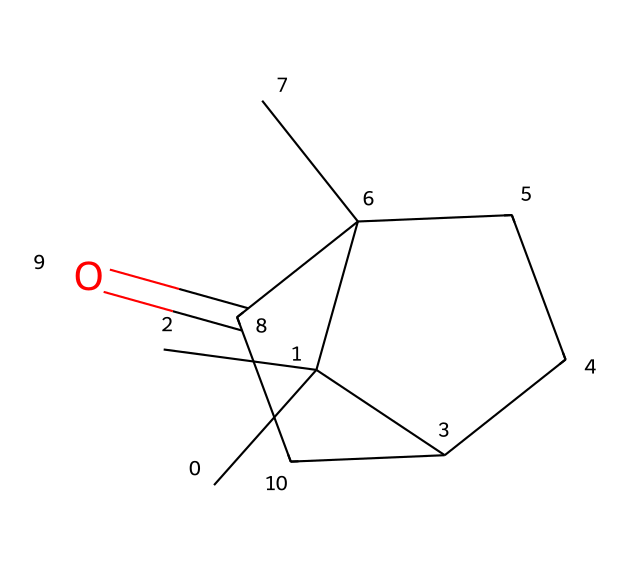How many carbon atoms are present in camphor? By analyzing the SMILES representation, we note each 'C' indicates a carbon atom. Counting all the 'C's in the structure shows there are ten carbon atoms in total.
Answer: ten What type of functional group is present in camphor? The structure contains a carbonyl group, indicated by the 'C(=O)' portion, which is characteristic of ketones. Therefore, the functional group in this compound is a ketone.
Answer: ketone How many rings are present in the structure of camphor? The structure of camphor presents two interconnected rings, as indicated by the cycloalkane format seen in the SMILES. Each cycloalkane contributes to the ring structure.
Answer: two What is the degree of saturation of camphor? The formula for calculating the degree of saturation (DBE) is the number of rings plus the number of double bonds. Camphor has two rings and one carbonyl; thus, the degree of saturation is two.
Answer: two What is the molecular formula of camphor? By analyzing the counts of carbon (C), hydrogen (H), and oxygen (O) from the SMILES, we arrive at the molecular formula C10H16O for camphor, summarizing its composition clearly.
Answer: C10H16O 